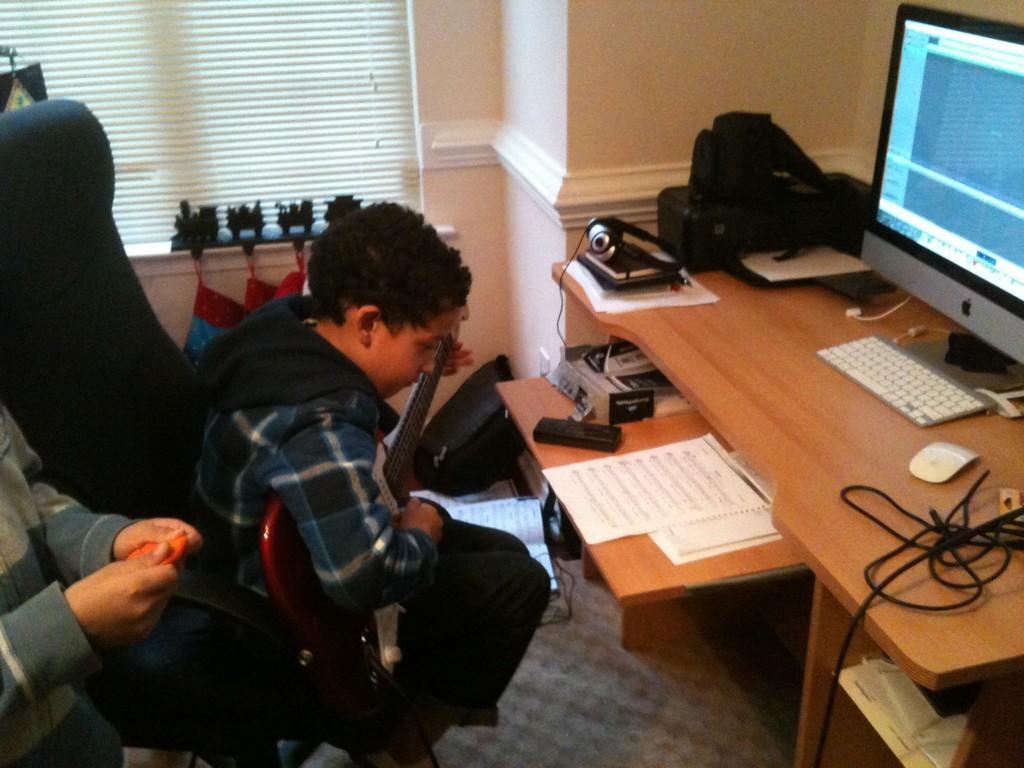In one or two sentences, can you explain what this image depicts? This man is sitting on a chair and playing guitar. On this table there are papers, keyboard, mouse, monitor, cable and things. This is window. 